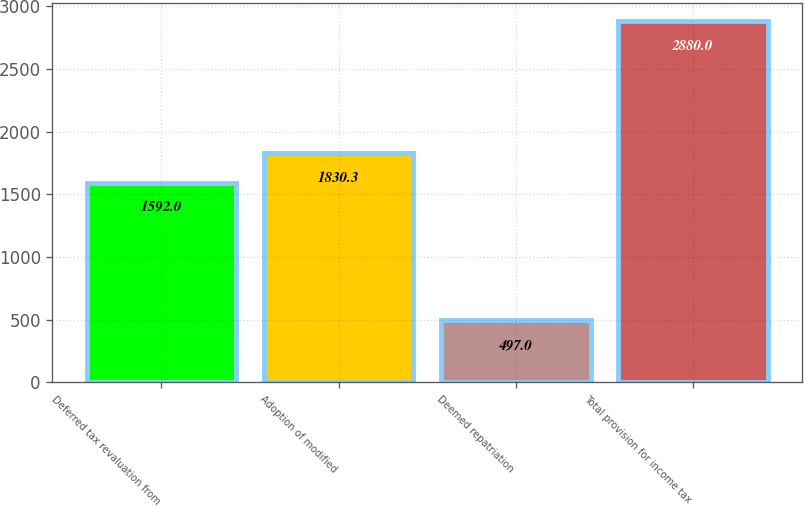Convert chart. <chart><loc_0><loc_0><loc_500><loc_500><bar_chart><fcel>Deferred tax revaluation from<fcel>Adoption of modified<fcel>Deemed repatriation<fcel>Total provision for income tax<nl><fcel>1592<fcel>1830.3<fcel>497<fcel>2880<nl></chart> 